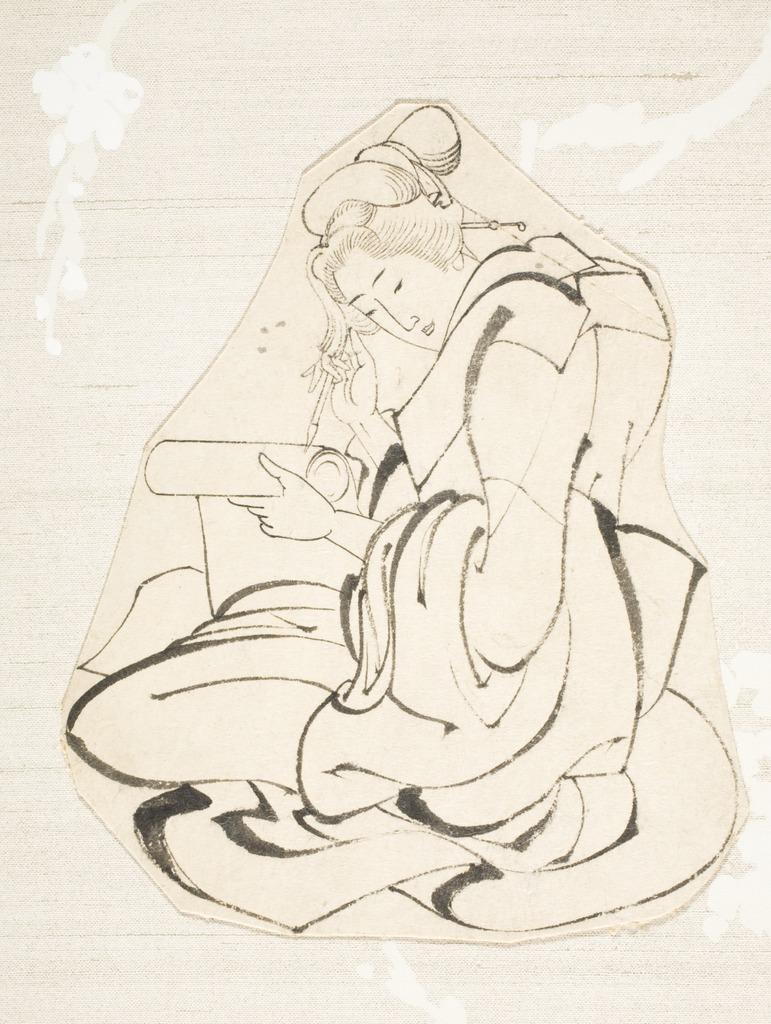What type of art is present in the image? The image contains art, but the specific type cannot be determined from the provided facts. Can you describe the subject of the art? The subject of the art cannot be determined from the provided facts. Is there a person depicted in the art? Yes, there is a woman in the image. What type of tax is being discussed in the image? There is no mention of tax in the image, as it contains art and a woman. How many times does the woman turn in the image? The woman does not turn in the image; she is depicted in a static pose. 